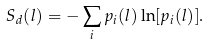Convert formula to latex. <formula><loc_0><loc_0><loc_500><loc_500>S _ { d } ( l ) = - \sum _ { i } p _ { i } ( l ) \ln [ p _ { i } ( l ) ] .</formula> 